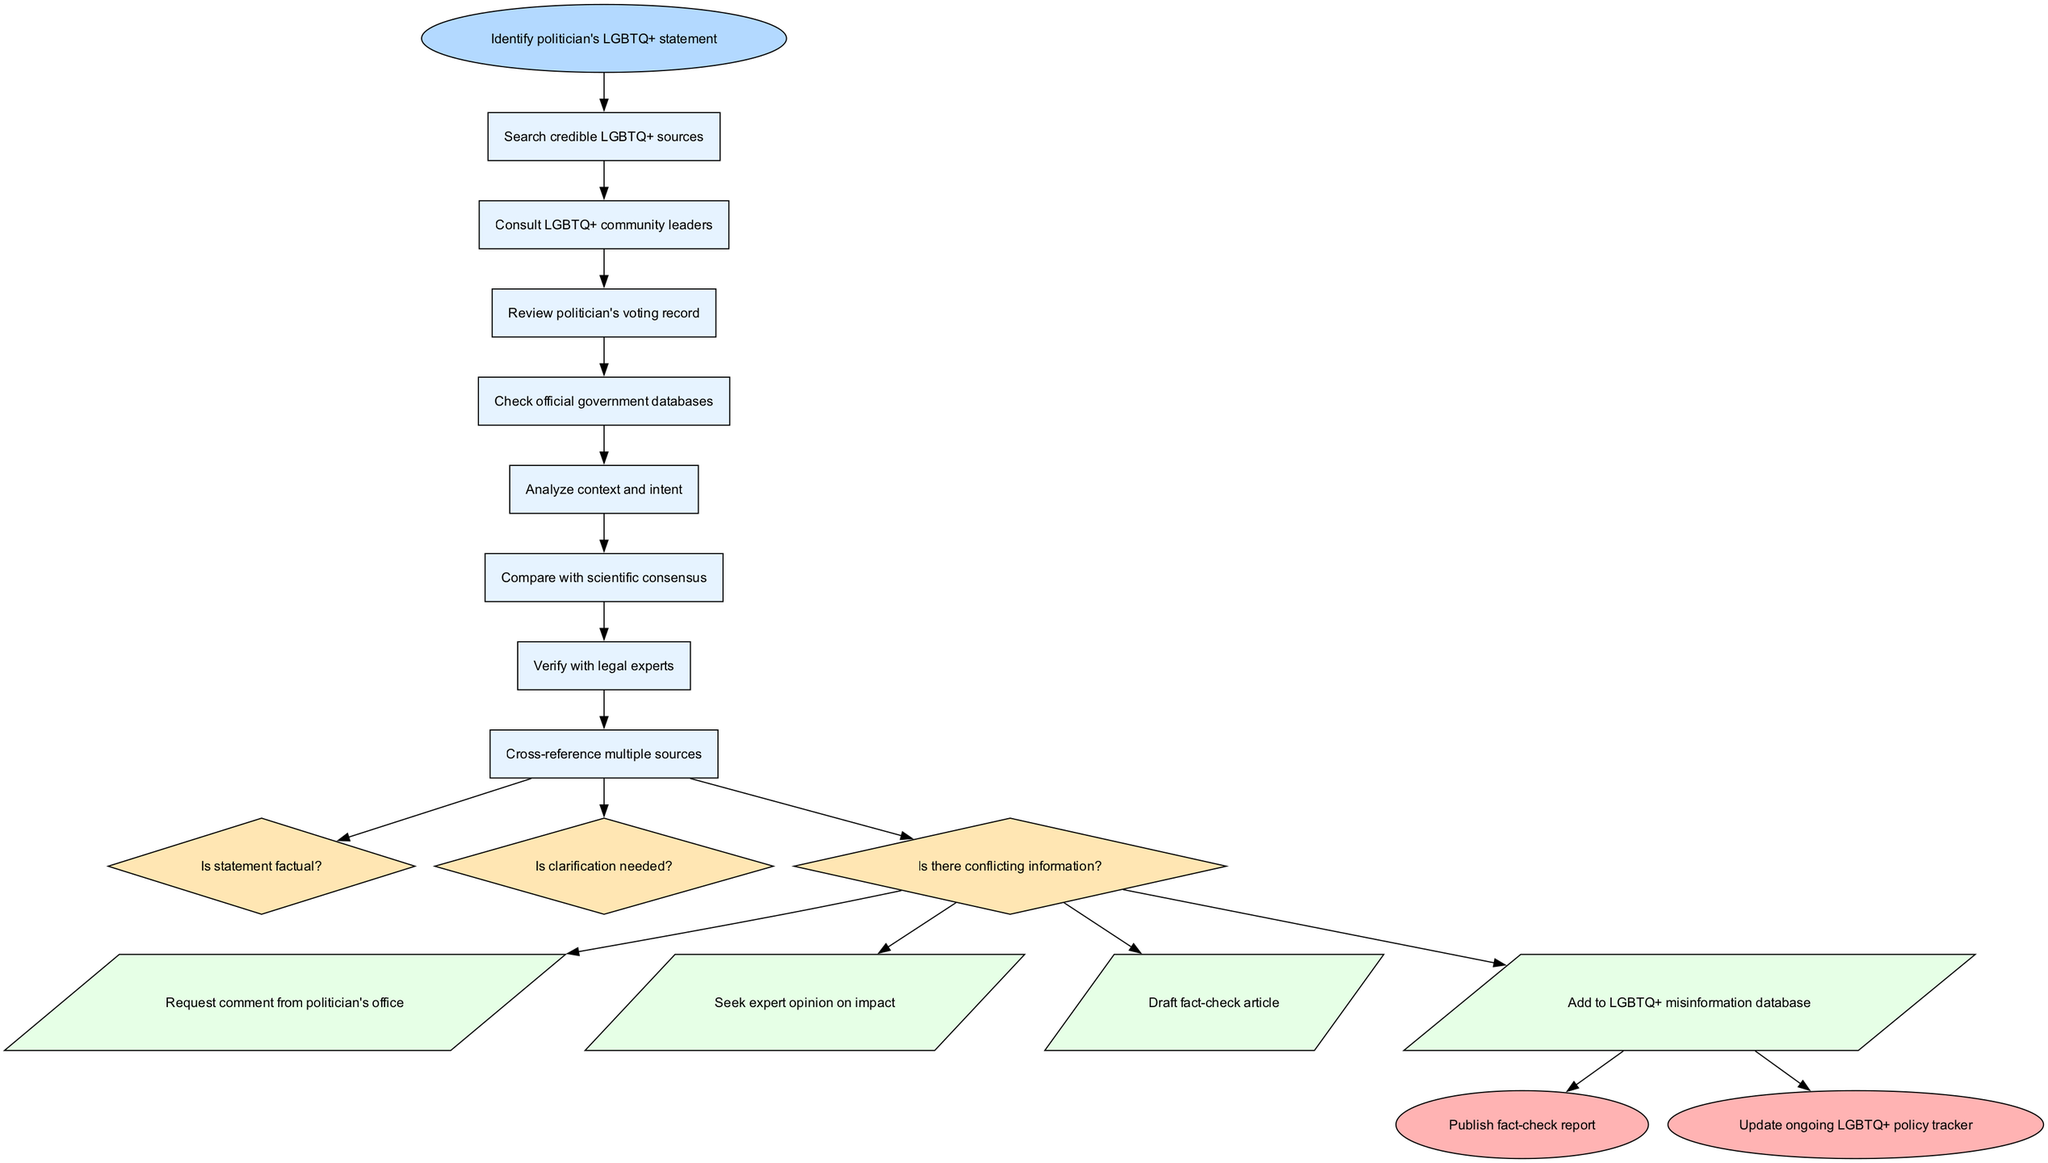What is the starting point of the fact-checking process? The starting point, or first node, of the process is "Identify politician's LGBTQ+ statement." This is indicated in the diagram as the initial action which leads into subsequent actions aimed at verification.
Answer: Identify politician's LGBTQ+ statement How many actions are listed in the diagram? By counting the items in the "actions" section of the diagram, there are four distinct actions specified. These actions are the steps taken after decisions in the process.
Answer: 4 What type of node follows the review of the politician's voting record? After the "Review politician's voting record," the next node is a decision node which asks, "Is statement factual?" This indicates that a decision needs to be made before proceeding further.
Answer: Decision node What is the final output of the fact-checking process? The diagram shows two possible endpoints as the final output: "Publish fact-check report" and "Update ongoing LGBTQ+ policy tracker." These outcomes signify the conclusions of the process.
Answer: Publish fact-check report, Update ongoing LGBTQ+ policy tracker What actions are taken if clarification is needed? If clarification is needed, the action indicated is to "Request comment from politician's office." This is the appropriate step to seek further information regarding the statement.
Answer: Request comment from politician's office How many decision nodes are present in the diagram? The diagram includes three decision nodes in total. Each decision prompts the fact-checker to advance in a particular direction based on the circumstances of the statement being evaluated.
Answer: 3 What is the relationship between the "Check official government databases" node and the "Analyze context and intent" node? The "Check official government databases" node leads directly to "Analyze context and intent," indicating that these actions are sequential in the flowchart, with one following the other to help clarify the verification process.
Answer: Sequential relationship What do you do if there's conflicting information? In case of conflicting information, the diagram specifies to "Seek expert opinion on impact." This suggests consulting specialized knowledge as a response to unclear data.
Answer: Seek expert opinion on impact 